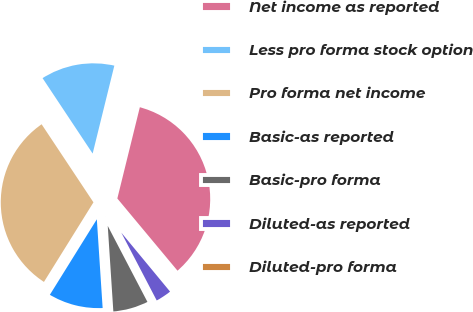<chart> <loc_0><loc_0><loc_500><loc_500><pie_chart><fcel>Net income as reported<fcel>Less pro forma stock option<fcel>Pro forma net income<fcel>Basic-as reported<fcel>Basic-pro forma<fcel>Diluted-as reported<fcel>Diluted-pro forma<nl><fcel>35.1%<fcel>13.18%<fcel>31.82%<fcel>9.9%<fcel>6.62%<fcel>3.34%<fcel>0.06%<nl></chart> 